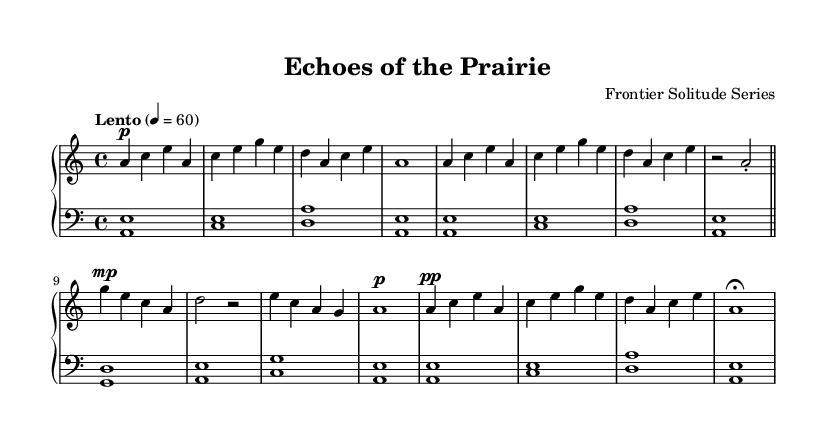What is the key signature of this music? The key signature is defined at the beginning of the score after the clef. In this music, there is one flat indicated, meaning it is in A minor (as it is the relative minor of C major and follows the same key signature).
Answer: A minor What is the time signature of the piece? The time signature is located at the beginning of the music, typically following the key signature. In this score, the indication is 4/4, which means there are four beats in a measure and a quarter note gets one beat.
Answer: 4/4 What is the tempo marking for the piece? The tempo marking appears right after the time signature and provides the speed of the piece. Here, "Lento" specifies a slow tempo, and the metronome marking of 60 indicates that there are 60 beats per minute.
Answer: Lento How many measures are in Section A? By counting the individual musical phrases grouped by vertical lines (bars) in Section A, we see there are four distinct measures. This can be visually verified by observing the notation until the repeat sign indicating the end of Section A.
Answer: 4 What is the dynamic marking for the first measure? The dynamic marking, which indicates the volume, is shown directly before the note in the first measure. In this context, the first measure has a "p" symbol, indicating that it should be played pianissimo (softly).
Answer: p Identify the type of texture predominantly used in this piece. The piece features a clear contrast between the upper and lower staffs, showcasing a mix of melodic and harmonic elements that are fundamental to minimalist pieces. The texture is predominantly homophonic, where the melody is supported by harmony.
Answer: Homophonic What is the overall form of the piece? By analyzing the structure, we can see that the piece is organized into distinct sections labeled A, A', B, and A''. This indicates a form of variation that is common in minimalist compositions, where a main theme is revisited and transformed.
Answer: A, A', B, A'' 